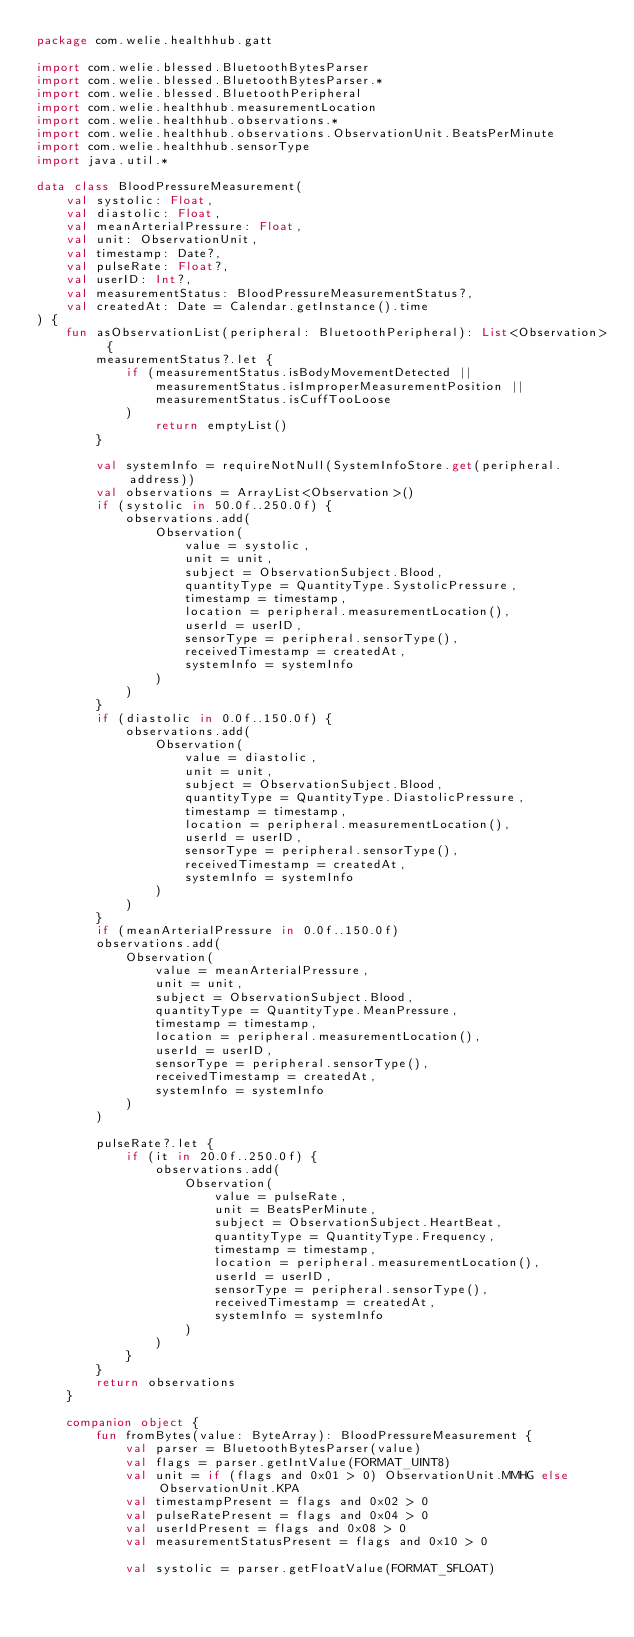Convert code to text. <code><loc_0><loc_0><loc_500><loc_500><_Kotlin_>package com.welie.healthhub.gatt

import com.welie.blessed.BluetoothBytesParser
import com.welie.blessed.BluetoothBytesParser.*
import com.welie.blessed.BluetoothPeripheral
import com.welie.healthhub.measurementLocation
import com.welie.healthhub.observations.*
import com.welie.healthhub.observations.ObservationUnit.BeatsPerMinute
import com.welie.healthhub.sensorType
import java.util.*

data class BloodPressureMeasurement(
    val systolic: Float,
    val diastolic: Float,
    val meanArterialPressure: Float,
    val unit: ObservationUnit,
    val timestamp: Date?,
    val pulseRate: Float?,
    val userID: Int?,
    val measurementStatus: BloodPressureMeasurementStatus?,
    val createdAt: Date = Calendar.getInstance().time
) {
    fun asObservationList(peripheral: BluetoothPeripheral): List<Observation> {
        measurementStatus?.let {
            if (measurementStatus.isBodyMovementDetected ||
                measurementStatus.isImproperMeasurementPosition ||
                measurementStatus.isCuffTooLoose
            )
                return emptyList()
        }

        val systemInfo = requireNotNull(SystemInfoStore.get(peripheral.address))
        val observations = ArrayList<Observation>()
        if (systolic in 50.0f..250.0f) {
            observations.add(
                Observation(
                    value = systolic,
                    unit = unit,
                    subject = ObservationSubject.Blood,
                    quantityType = QuantityType.SystolicPressure,
                    timestamp = timestamp,
                    location = peripheral.measurementLocation(),
                    userId = userID,
                    sensorType = peripheral.sensorType(),
                    receivedTimestamp = createdAt,
                    systemInfo = systemInfo
                )
            )
        }
        if (diastolic in 0.0f..150.0f) {
            observations.add(
                Observation(
                    value = diastolic,
                    unit = unit,
                    subject = ObservationSubject.Blood,
                    quantityType = QuantityType.DiastolicPressure,
                    timestamp = timestamp,
                    location = peripheral.measurementLocation(),
                    userId = userID,
                    sensorType = peripheral.sensorType(),
                    receivedTimestamp = createdAt,
                    systemInfo = systemInfo
                )
            )
        }
        if (meanArterialPressure in 0.0f..150.0f)
        observations.add(
            Observation(
                value = meanArterialPressure,
                unit = unit,
                subject = ObservationSubject.Blood,
                quantityType = QuantityType.MeanPressure,
                timestamp = timestamp,
                location = peripheral.measurementLocation(),
                userId = userID,
                sensorType = peripheral.sensorType(),
                receivedTimestamp = createdAt,
                systemInfo = systemInfo
            )
        )

        pulseRate?.let {
            if (it in 20.0f..250.0f) {
                observations.add(
                    Observation(
                        value = pulseRate,
                        unit = BeatsPerMinute,
                        subject = ObservationSubject.HeartBeat,
                        quantityType = QuantityType.Frequency,
                        timestamp = timestamp,
                        location = peripheral.measurementLocation(),
                        userId = userID,
                        sensorType = peripheral.sensorType(),
                        receivedTimestamp = createdAt,
                        systemInfo = systemInfo
                    )
                )
            }
        }
        return observations
    }

    companion object {
        fun fromBytes(value: ByteArray): BloodPressureMeasurement {
            val parser = BluetoothBytesParser(value)
            val flags = parser.getIntValue(FORMAT_UINT8)
            val unit = if (flags and 0x01 > 0) ObservationUnit.MMHG else ObservationUnit.KPA
            val timestampPresent = flags and 0x02 > 0
            val pulseRatePresent = flags and 0x04 > 0
            val userIdPresent = flags and 0x08 > 0
            val measurementStatusPresent = flags and 0x10 > 0

            val systolic = parser.getFloatValue(FORMAT_SFLOAT)</code> 